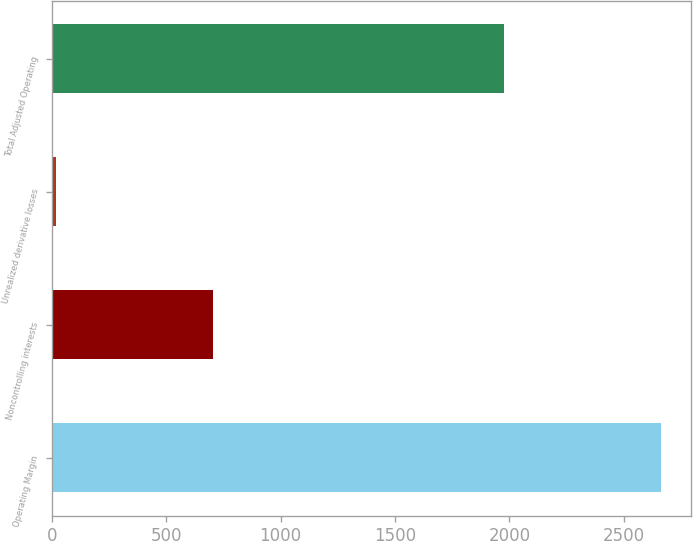Convert chart to OTSL. <chart><loc_0><loc_0><loc_500><loc_500><bar_chart><fcel>Operating Margin<fcel>Noncontrolling interests<fcel>Unrealized derivative losses<fcel>Total Adjusted Operating<nl><fcel>2663<fcel>705<fcel>19<fcel>1977<nl></chart> 